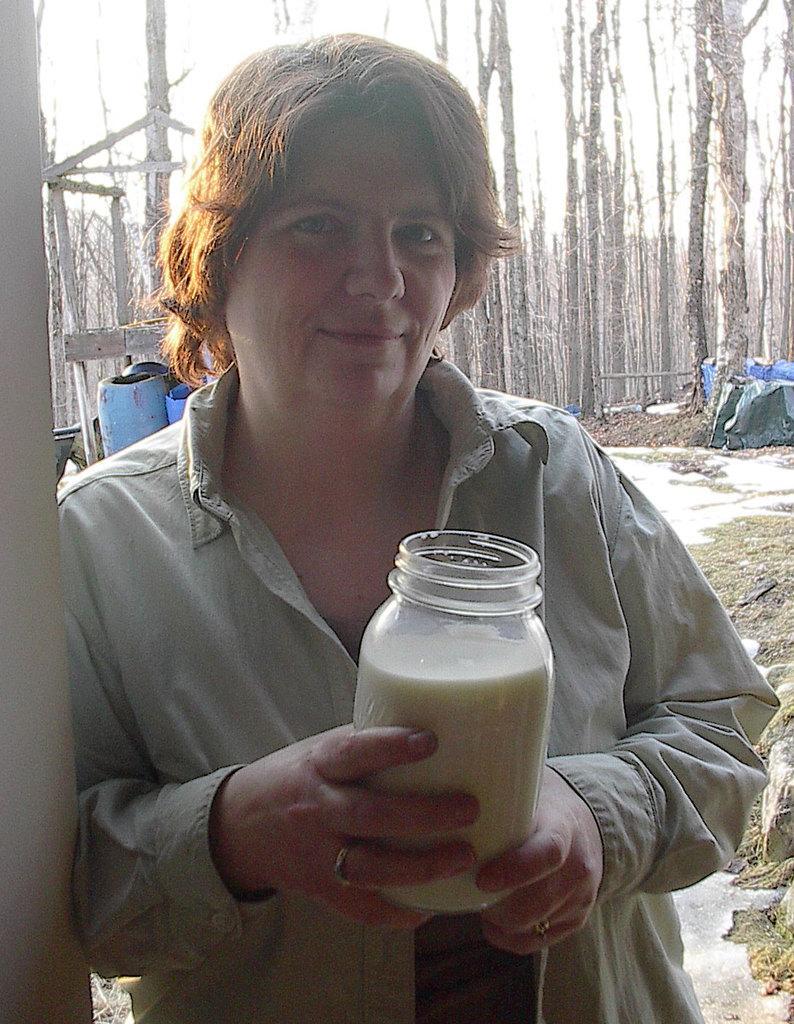In one or two sentences, can you explain what this image depicts? In the foreground of this picture, there is a woman standing and holding a jar and there seems to be like milk in side it. In the background, there are trees, grass, drums and covers. 